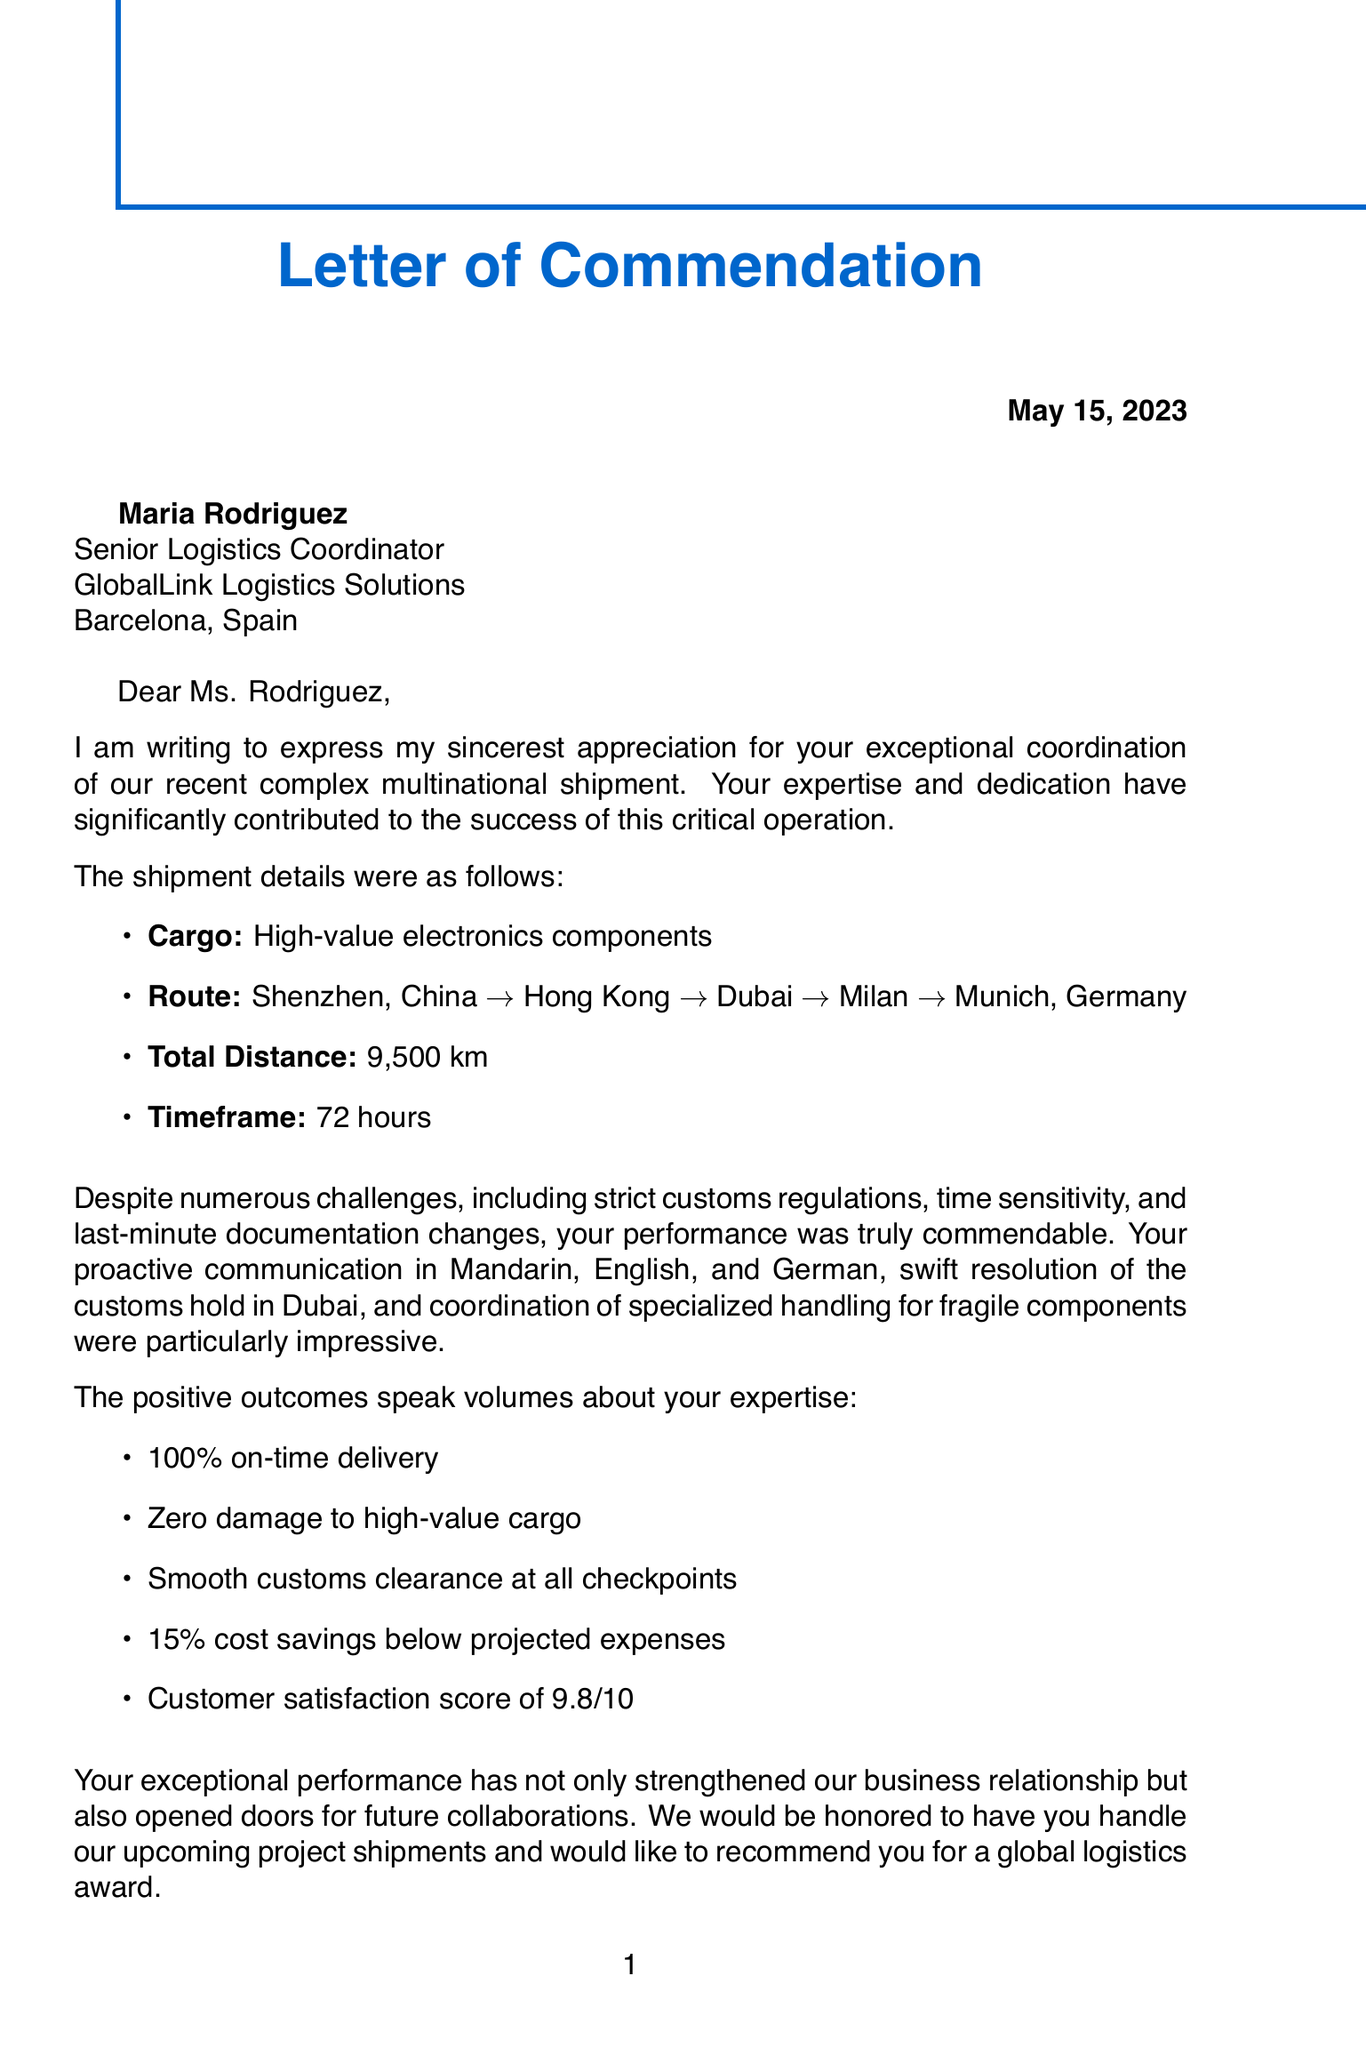What is the name of the sender? The sender of the letter is identified as Sophia Chen.
Answer: Sophia Chen What is the date of the letter? The date when the letter was written is explicitly mentioned in the document.
Answer: May 15, 2023 What was the total distance of the shipment? The document states the total distance the shipment traveled as part of its details.
Answer: 9,500 km What was the on-time delivery percentage? The letter provides a metric specifically mentioning the percentage of on-time deliveries.
Answer: 100% What language skills did Maria Rodriguez use in coordination? The document highlights the languages used by Maria Rodriguez during the shipment coordination.
Answer: Mandarin, English, and German What was the customer satisfaction score? The letter mentions a specific score that reflects customer satisfaction with the service.
Answer: 9.8/10 What were the challenges faced during the shipment coordination? The letter lists multiple challenges, including strict regulations and time sensitivity, which had to be overcome.
Answer: Strict customs regulations in multiple countries What is one of the future collaboration opportunities mentioned? The document outlines opportunities for continued partnership and specific future engagements.
Answer: Invitation to handle upcoming project shipments How much were the cost savings achieved? The letter states that there were savings compared to expected expenditures during the shipment process.
Answer: 15% below projected expenses 